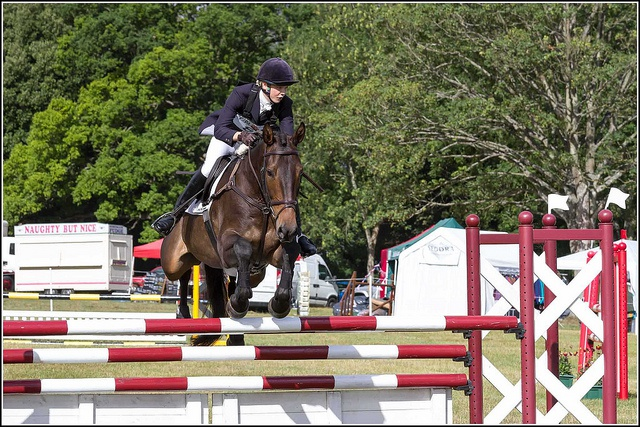Describe the objects in this image and their specific colors. I can see horse in black, gray, and maroon tones, truck in black, white, darkgray, and gray tones, people in black, gray, and white tones, truck in black, lightgray, darkgray, and gray tones, and car in black, brown, gray, salmon, and maroon tones in this image. 